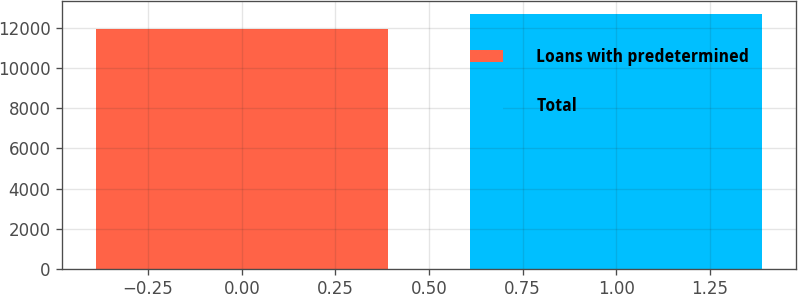Convert chart. <chart><loc_0><loc_0><loc_500><loc_500><bar_chart><fcel>Loans with predetermined<fcel>Total<nl><fcel>11974<fcel>12730<nl></chart> 